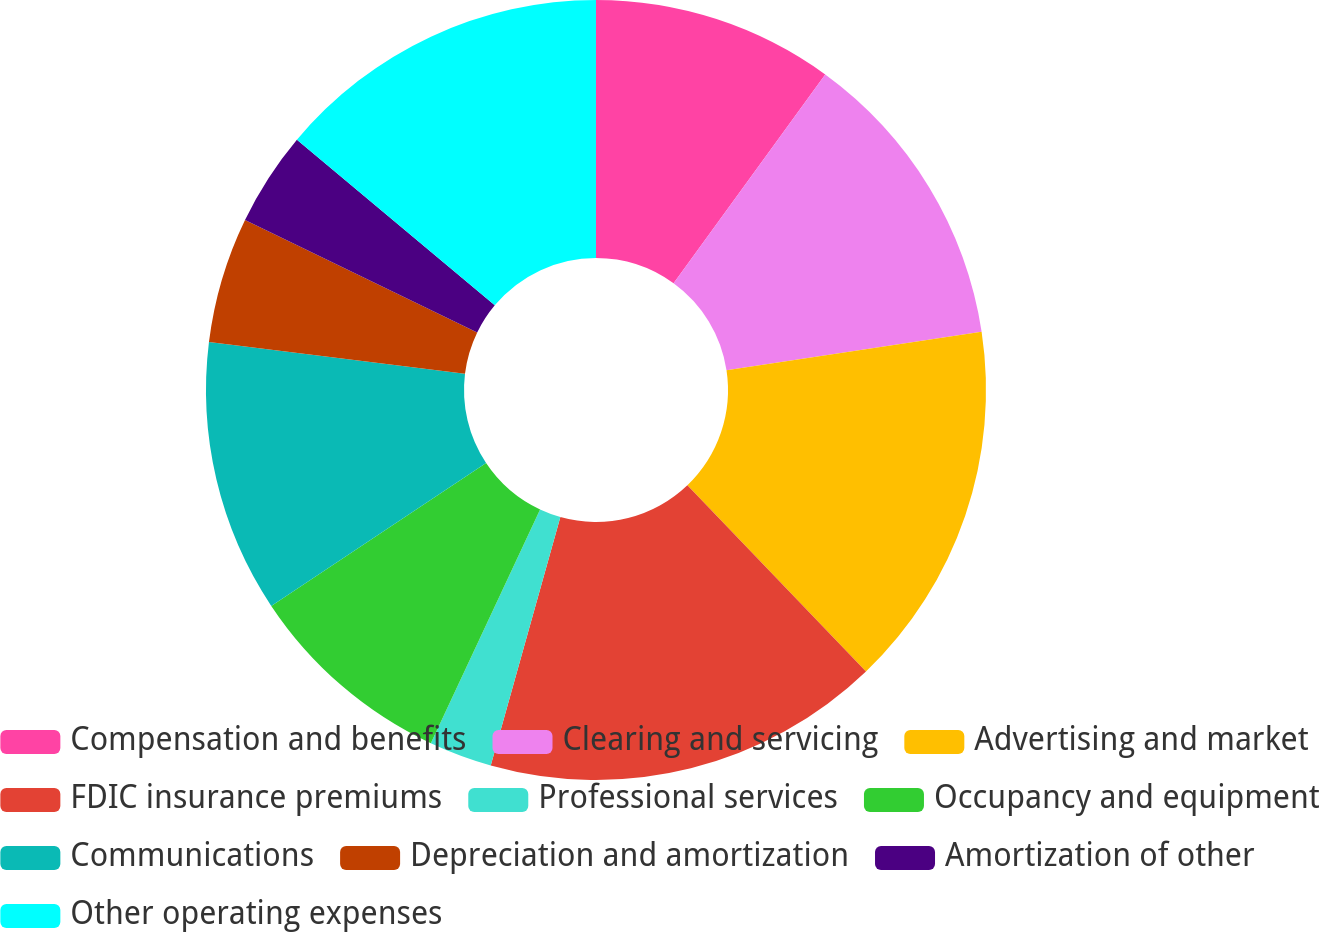<chart> <loc_0><loc_0><loc_500><loc_500><pie_chart><fcel>Compensation and benefits<fcel>Clearing and servicing<fcel>Advertising and market<fcel>FDIC insurance premiums<fcel>Professional services<fcel>Occupancy and equipment<fcel>Communications<fcel>Depreciation and amortization<fcel>Amortization of other<fcel>Other operating expenses<nl><fcel>10.0%<fcel>12.61%<fcel>15.22%<fcel>16.52%<fcel>2.61%<fcel>8.7%<fcel>11.3%<fcel>5.22%<fcel>3.91%<fcel>13.91%<nl></chart> 